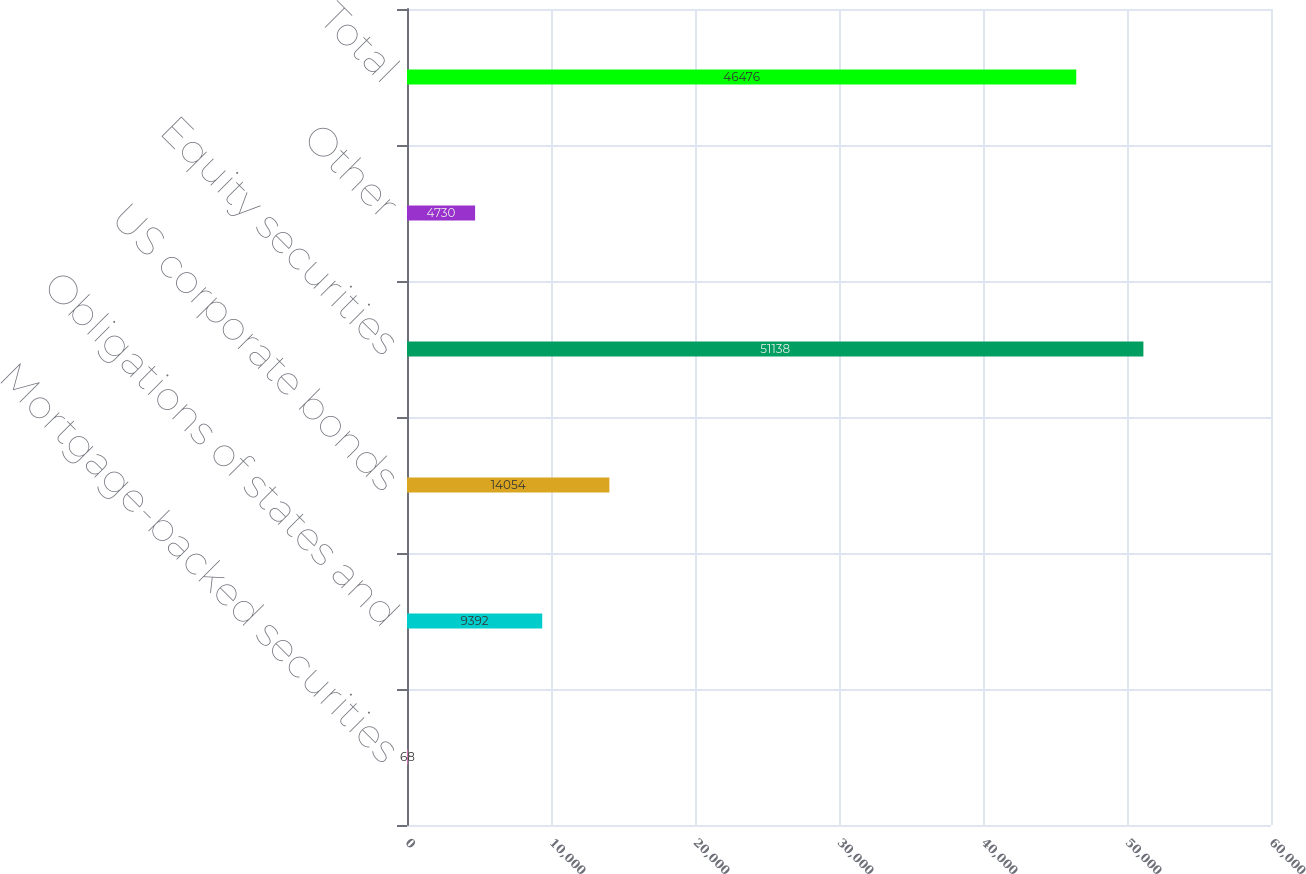<chart> <loc_0><loc_0><loc_500><loc_500><bar_chart><fcel>Mortgage-backed securities<fcel>Obligations of states and<fcel>US corporate bonds<fcel>Equity securities<fcel>Other<fcel>Total<nl><fcel>68<fcel>9392<fcel>14054<fcel>51138<fcel>4730<fcel>46476<nl></chart> 